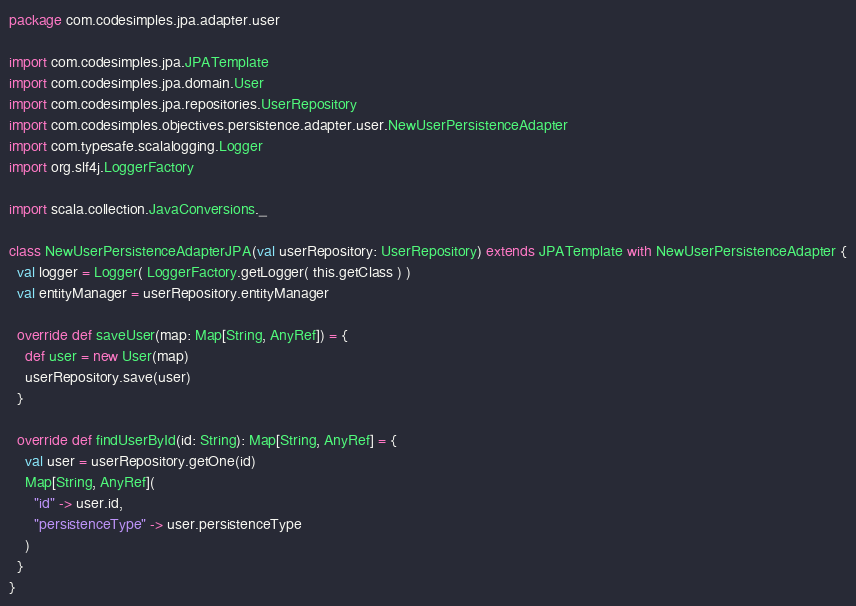<code> <loc_0><loc_0><loc_500><loc_500><_Scala_>package com.codesimples.jpa.adapter.user

import com.codesimples.jpa.JPATemplate
import com.codesimples.jpa.domain.User
import com.codesimples.jpa.repositories.UserRepository
import com.codesimples.objectives.persistence.adapter.user.NewUserPersistenceAdapter
import com.typesafe.scalalogging.Logger
import org.slf4j.LoggerFactory

import scala.collection.JavaConversions._

class NewUserPersistenceAdapterJPA(val userRepository: UserRepository) extends JPATemplate with NewUserPersistenceAdapter {
  val logger = Logger( LoggerFactory.getLogger( this.getClass ) )
  val entityManager = userRepository.entityManager

  override def saveUser(map: Map[String, AnyRef]) = {
    def user = new User(map)
    userRepository.save(user)
  }

  override def findUserById(id: String): Map[String, AnyRef] = {
    val user = userRepository.getOne(id)
    Map[String, AnyRef](
      "id" -> user.id,
      "persistenceType" -> user.persistenceType
    )
  }
}
</code> 